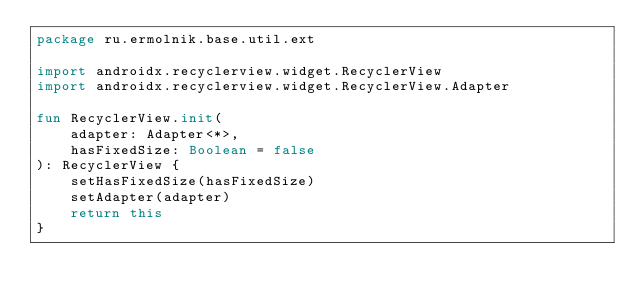Convert code to text. <code><loc_0><loc_0><loc_500><loc_500><_Kotlin_>package ru.ermolnik.base.util.ext

import androidx.recyclerview.widget.RecyclerView
import androidx.recyclerview.widget.RecyclerView.Adapter

fun RecyclerView.init(
    adapter: Adapter<*>,
    hasFixedSize: Boolean = false
): RecyclerView {
    setHasFixedSize(hasFixedSize)
    setAdapter(adapter)
    return this
}
</code> 